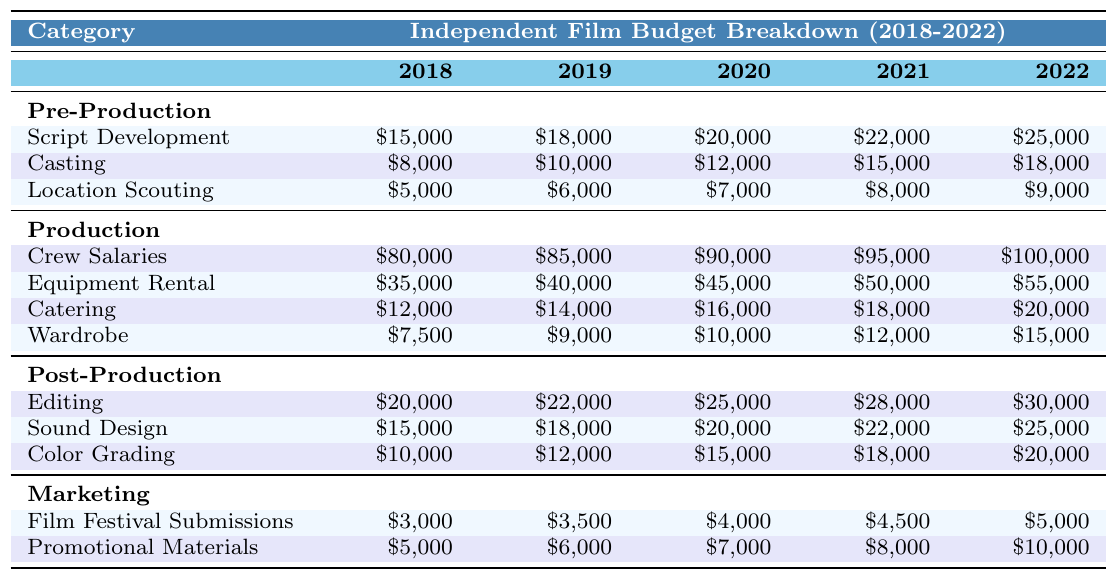What was the total budget for Production in 2019? The total for Production in 2019 is found by adding the values for Crew Salaries ($85,000), Equipment Rental ($40,000), Catering ($14,000), and Wardrobe ($9,000), which equals $85,000 + $40,000 + $14,000 + $9,000 = $148,000.
Answer: $148,000 Which category saw the highest increase in budget from 2021 to 2022? Comparing the budget increases for each category from 2021 to 2022: Pre-Production had an increase of $5,000 for Script Development, $3,000 for Casting, and $1,000 for Location Scouting; Production had increases of $5,000 for all four subcategories; Post-Production had increases of $2,000 for Editing, $3,000 for Sound Design, and $2,000 for Color Grading; Marketing had increases of $500 and $2,000 for its subcategories. The largest increase is in Production, with a total increase of $20,000.
Answer: Production What was the average budget for Post-Production across all years? To calculate the average, sum the budgets for Editing ($15,000 in 2018, $22,000 in 2019, $25,000 in 2020, $28,000 in 2021, $30,000 in 2022), Sound Design ($15,000, $18,000, $20,000, $22,000, $25,000), and Color Grading ($10,000, $12,000, $15,000, $18,000, $20,000). The total sums are: Editing = $110,000, Sound Design = $100,000, and Color Grading = $75,000. Adding them gives $110,000 + $100,000 + $75,000 = $285,000. There are 15 values (5 from each category), so the average is $285,000 / 15 = $19,000.
Answer: $19,000 Did Spending on Marketing increase every year from 2018 to 2022? Looking at the Marketing budgets for each year, Film Festival Submissions spent $3,000 in 2018, $3,500 in 2019, $4,000 in 2020, $4,500 in 2021, and $5,000 in 2022, showing an increase. Promotional Materials saw $5,000 in 2018, $6,000 in 2019, $7,000 in 2020, $8,000 in 2021, and $10,000 in 2022, also showing an increase. Both categories increased each year.
Answer: Yes What is the total amount spent on Pre-Production in 2020? The total for Pre-Production in 2020 is found by adding Script Development ($20,000), Casting ($12,000), and Location Scouting ($7,000), which equals $20,000 + $12,000 + $7,000 = $39,000.
Answer: $39,000 Which budget category had the highest expenditures in 2022? In 2022, the expenditures were Crew Salaries ($100,000) and Equipment Rental ($55,000) in Production, which are the highest among all categories for that year.
Answer: Production What was the cumulative budget for Casting from 2018 to 2022? To find the cumulative budget for Casting, add the amounts for each year: $8,000 (2018) + $10,000 (2019) + $12,000 (2020) + $15,000 (2021) + $18,000 (2022) = $63,000.
Answer: $63,000 Which year had the highest spending in the Editing category? The values for Editing are $20,000 (2018), $22,000 (2019), $25,000 (2020), $28,000 (2021), and $30,000 (2022). The highest spending occurred in 2022 with $30,000.
Answer: 2022 Was the total spent on Equipment Rental higher in 2019 than in 2018? Equipment Rental for 2018 was $35,000 and for 2019 it was $40,000. Since $40,000 is greater than $35,000, the statement is true.
Answer: Yes What is the sum of the Marketing budget across all years? The total for Marketing is calculated by adding Film Festival Submissions ($3,000 + $3,500 + $4,000 + $4,500 + $5,000) and Promotional Materials ($5,000 + $6,000 + $7,000 + $8,000 + $10,000). This totals $3,000 + $3,500 + $4,000 + $4,500 + $5,000 + $5,000 + $6,000 + $7,000 + $8,000 + $10,000 = $56,000.
Answer: $56,000 